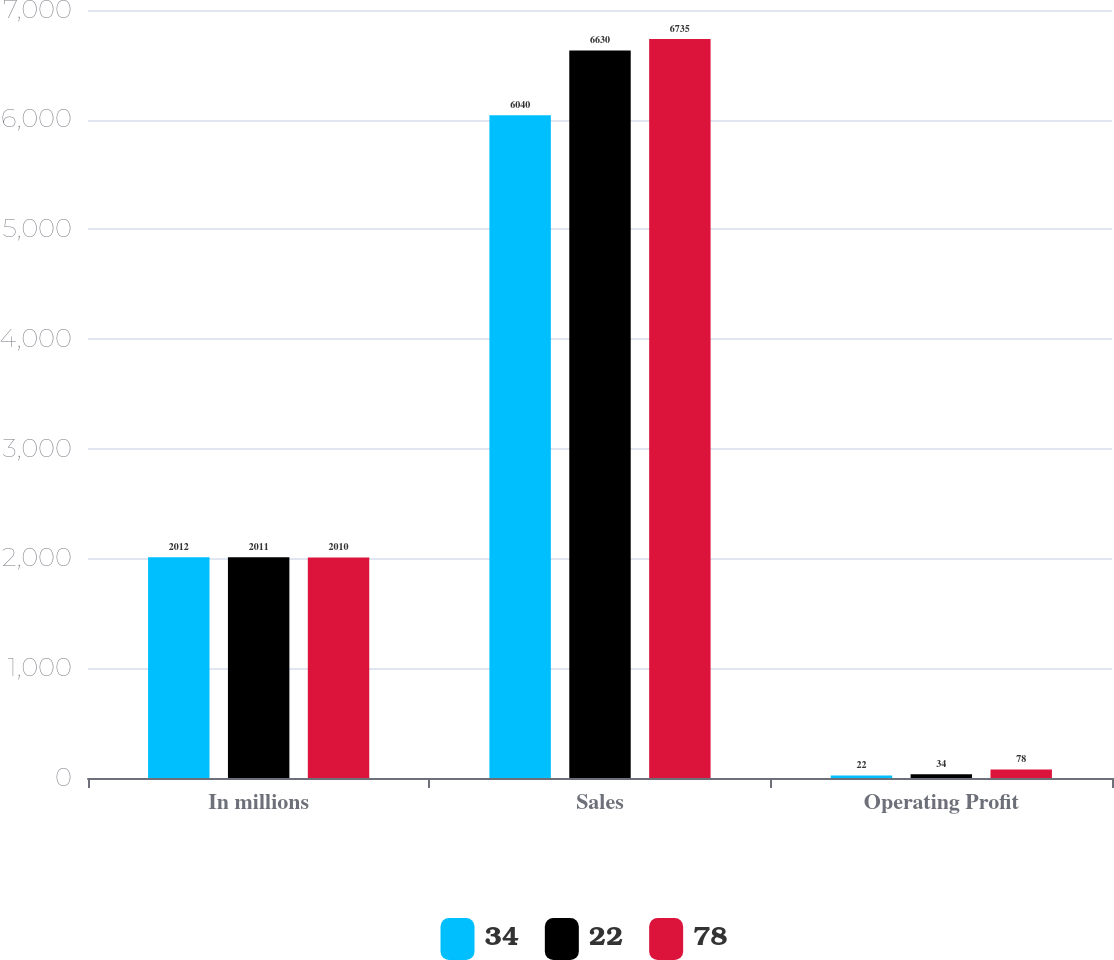<chart> <loc_0><loc_0><loc_500><loc_500><stacked_bar_chart><ecel><fcel>In millions<fcel>Sales<fcel>Operating Profit<nl><fcel>34<fcel>2012<fcel>6040<fcel>22<nl><fcel>22<fcel>2011<fcel>6630<fcel>34<nl><fcel>78<fcel>2010<fcel>6735<fcel>78<nl></chart> 